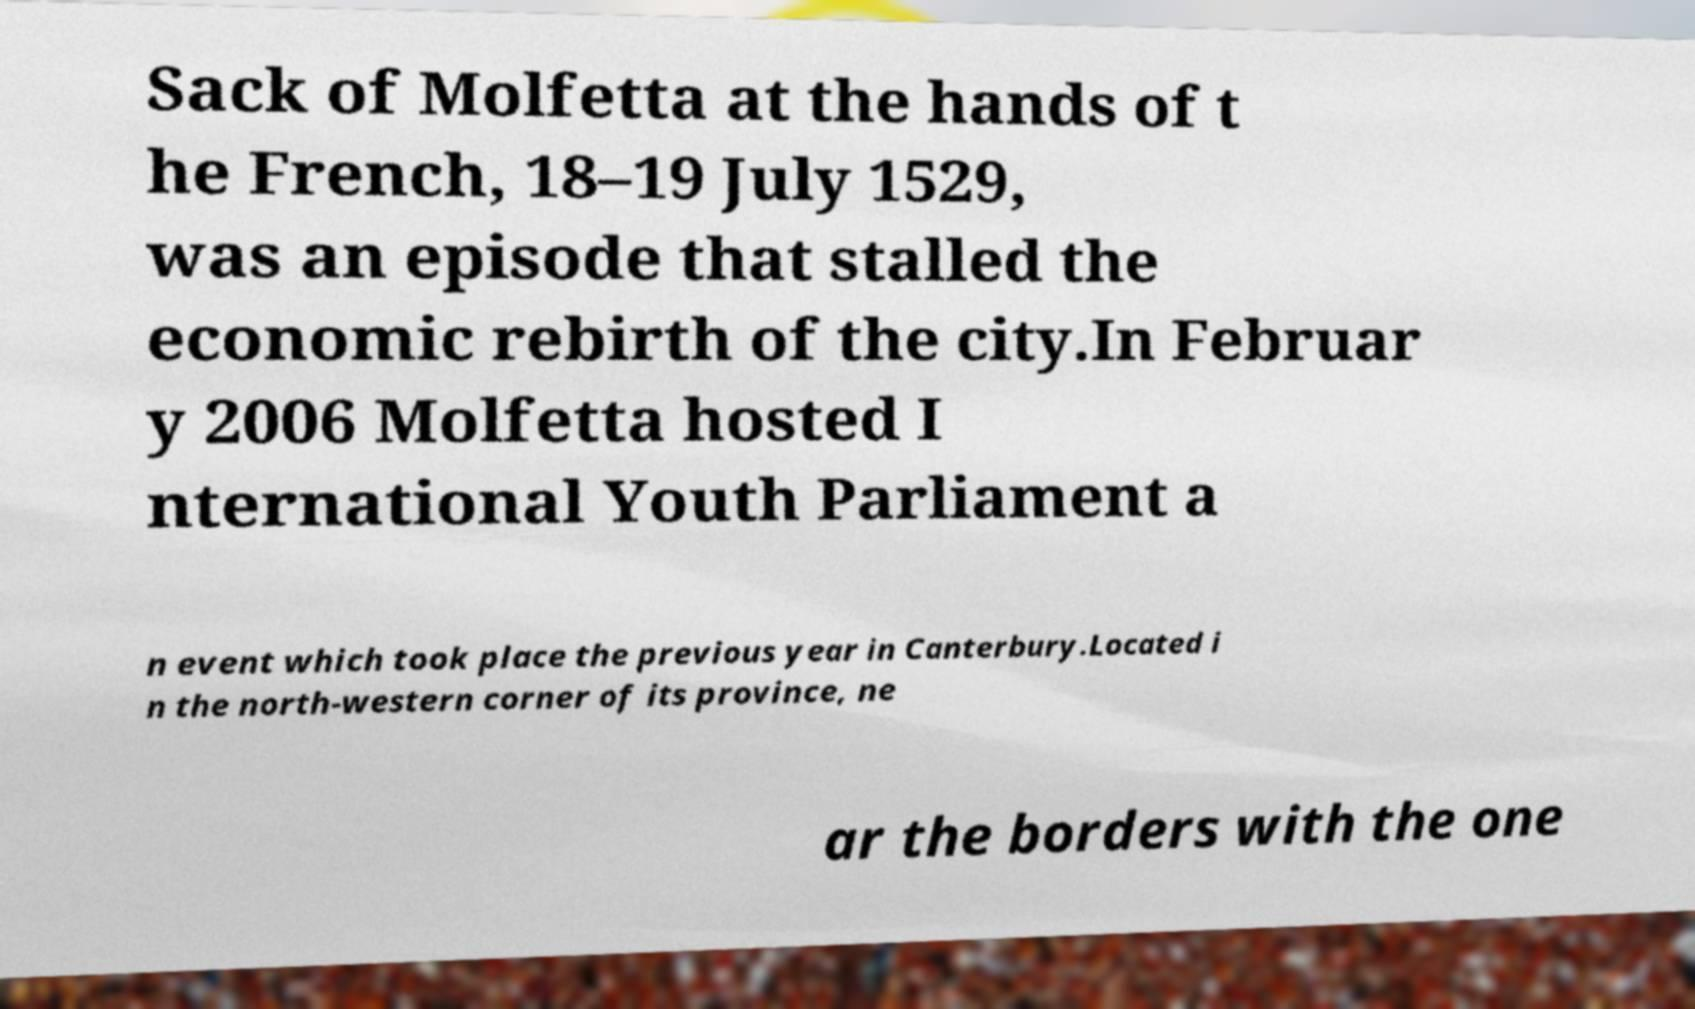Please identify and transcribe the text found in this image. Sack of Molfetta at the hands of t he French, 18–19 July 1529, was an episode that stalled the economic rebirth of the city.In Februar y 2006 Molfetta hosted I nternational Youth Parliament a n event which took place the previous year in Canterbury.Located i n the north-western corner of its province, ne ar the borders with the one 